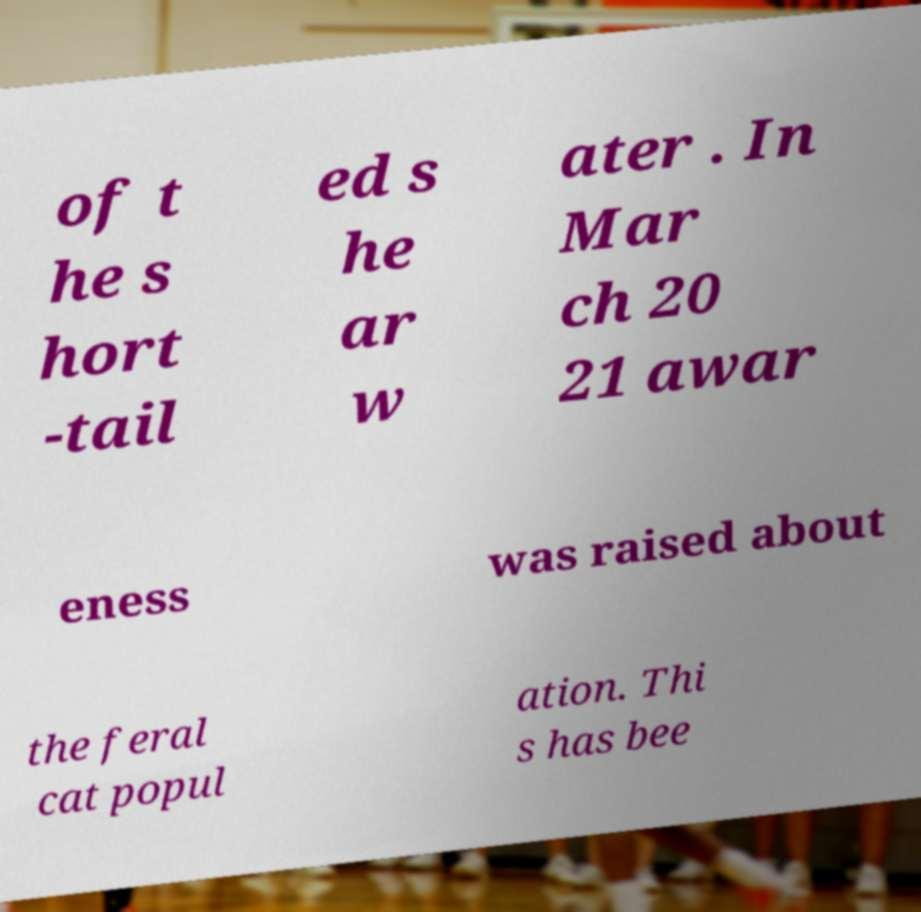Could you extract and type out the text from this image? of t he s hort -tail ed s he ar w ater . In Mar ch 20 21 awar eness was raised about the feral cat popul ation. Thi s has bee 